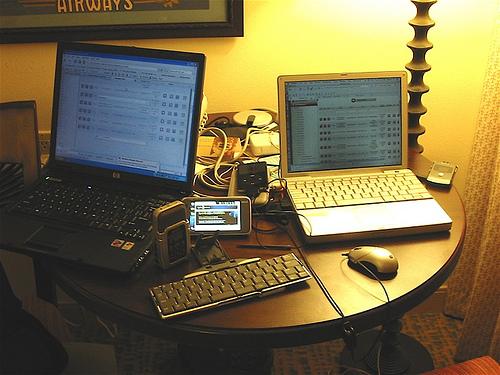What color is the mouse?
Short answer required. Silver. What shape is the table?
Write a very short answer. Round. Are the monitors showing the same thing?
Give a very brief answer. Yes. Is the computer on?
Short answer required. Yes. 